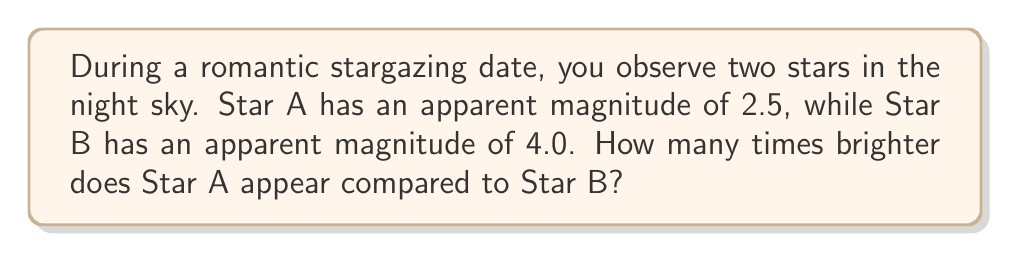Teach me how to tackle this problem. To solve this problem, we need to use the magnitude scale and the relationship between magnitude difference and brightness ratio. Let's break it down step-by-step:

1. Recall the relationship between magnitude difference and brightness ratio:
   
   $$\frac{B_1}{B_2} = 100^{\frac{m_2 - m_1}{5}}$$

   Where $B_1$ and $B_2$ are the brightnesses of the two stars, and $m_1$ and $m_2$ are their respective magnitudes.

2. In this case:
   $m_1 = 2.5$ (Star A)
   $m_2 = 4.0$ (Star B)

3. Plug these values into the equation:

   $$\frac{B_A}{B_B} = 100^{\frac{4.0 - 2.5}{5}}$$

4. Simplify the exponent:
   
   $$\frac{B_A}{B_B} = 100^{\frac{1.5}{5}} = 100^{0.3}$$

5. Calculate the result:
   
   $$\frac{B_A}{B_B} = 10^{0.3 \times 2} \approx 3.98$$

6. Round to two decimal places:
   
   $$\frac{B_A}{B_B} \approx 3.98$$

Therefore, Star A appears approximately 3.98 times brighter than Star B.
Answer: Star A appears approximately 3.98 times brighter than Star B. 